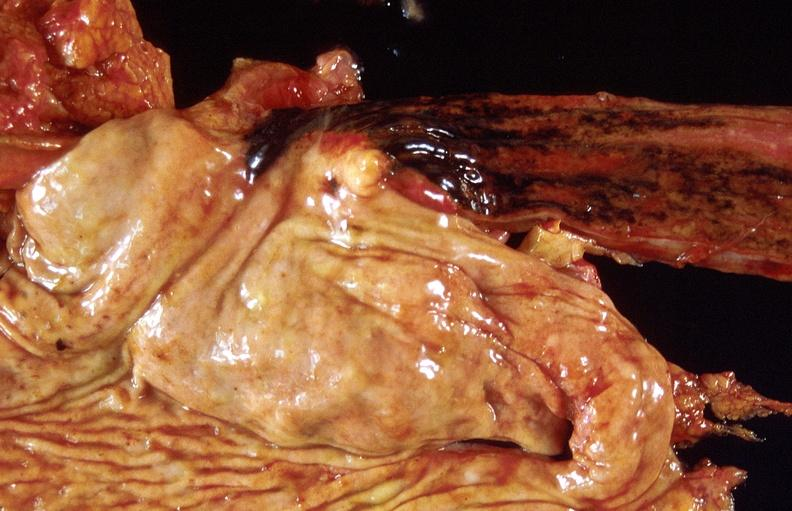what is present?
Answer the question using a single word or phrase. Gastrointestinal 